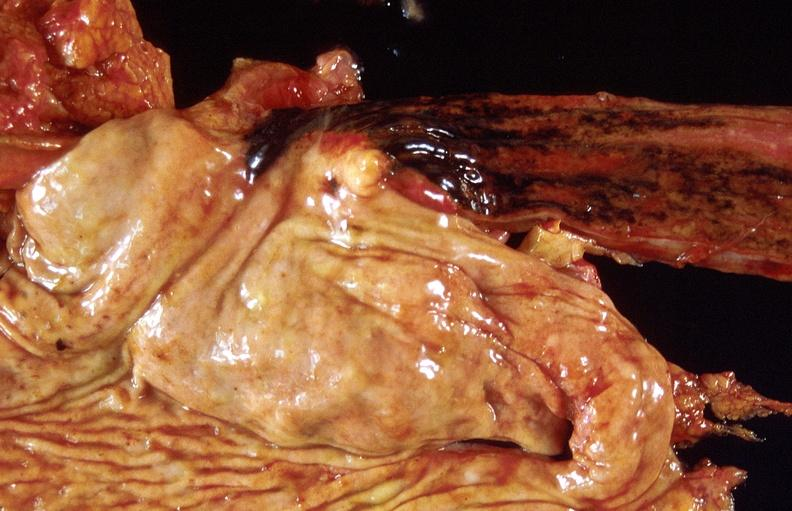what is present?
Answer the question using a single word or phrase. Gastrointestinal 